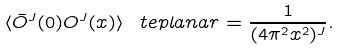<formula> <loc_0><loc_0><loc_500><loc_500>\langle \bar { O } ^ { J } ( 0 ) O ^ { J } ( x ) \rangle _ { \ } t e { p l a n a r } = \frac { 1 } { ( 4 \pi ^ { 2 } x ^ { 2 } ) ^ { J } } .</formula> 